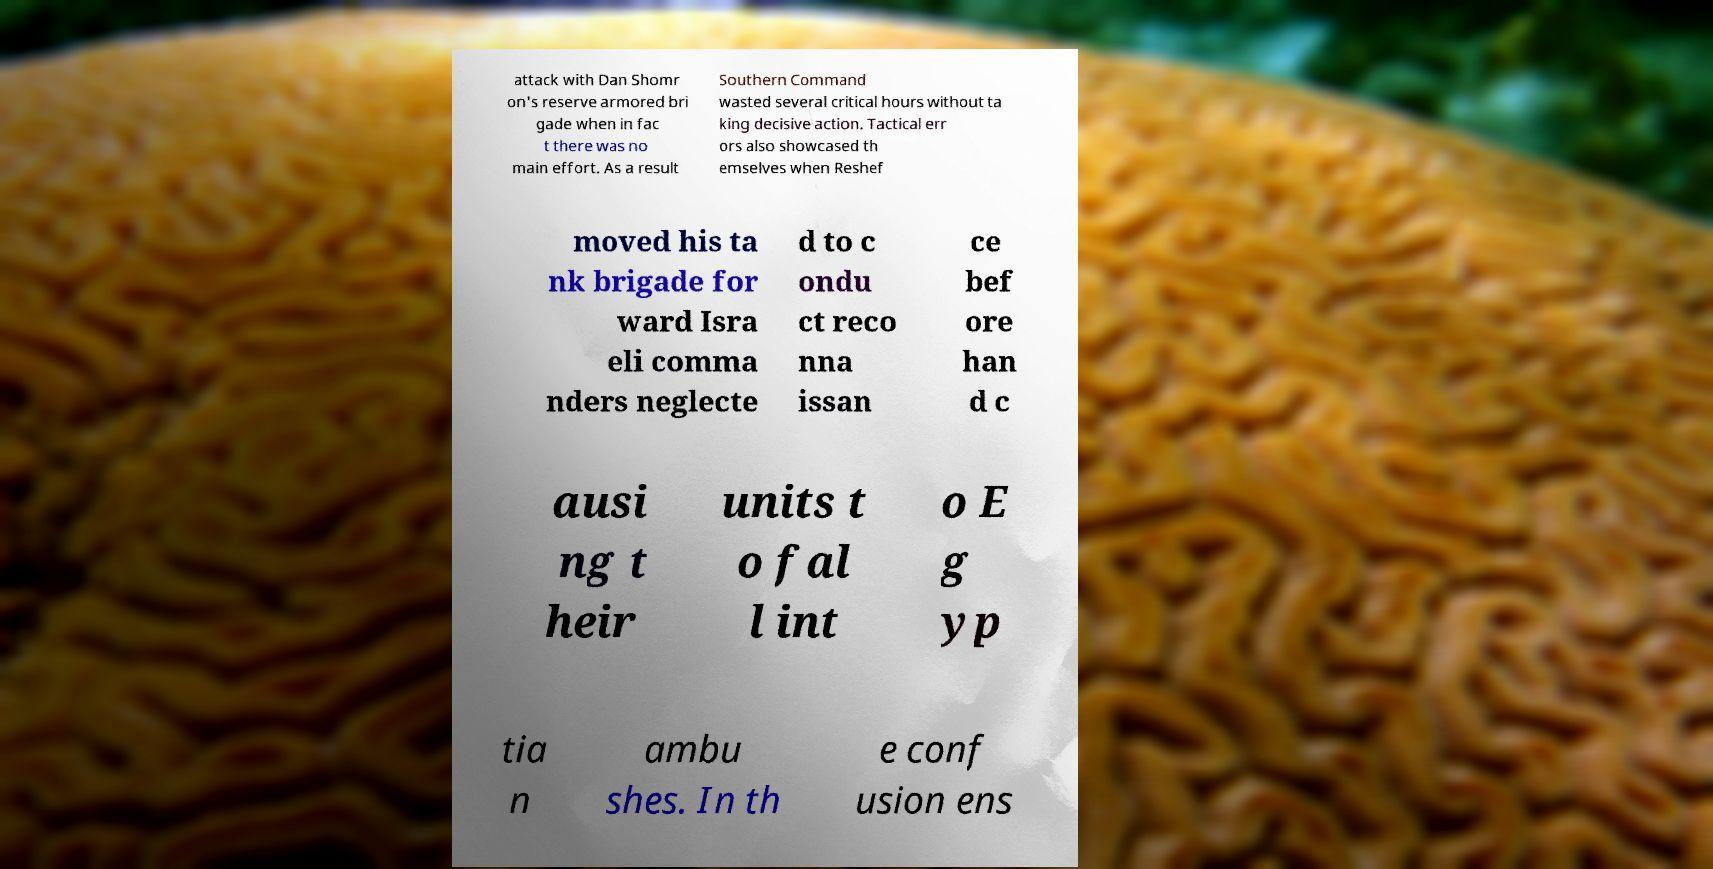Could you assist in decoding the text presented in this image and type it out clearly? attack with Dan Shomr on's reserve armored bri gade when in fac t there was no main effort. As a result Southern Command wasted several critical hours without ta king decisive action. Tactical err ors also showcased th emselves when Reshef moved his ta nk brigade for ward Isra eli comma nders neglecte d to c ondu ct reco nna issan ce bef ore han d c ausi ng t heir units t o fal l int o E g yp tia n ambu shes. In th e conf usion ens 